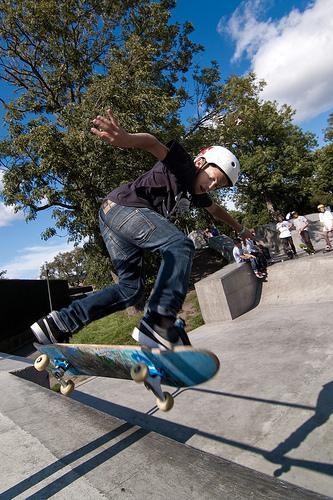Question: what is the person in the foreground doing?
Choices:
A. Roller skating.
B. Surfing.
C. Skateboarding.
D. Riding a bike.
Answer with the letter. Answer: C Question: what is the person in the foreground wearing on their head?
Choices:
A. Knit cap.
B. Helmet.
C. Ball cap.
D. Earphones.
Answer with the letter. Answer: B Question: where is this taking place?
Choices:
A. The game.
B. In a skatepark.
C. The dance.
D. The picnic.
Answer with the letter. Answer: B Question: what is the person in the foreground standing on?
Choices:
A. Sidewalk.
B. Stage.
C. Skateboard.
D. Stairs.
Answer with the letter. Answer: C Question: what kind of pants is the person in the foreground wearing?
Choices:
A. Yoga.
B. Jeans.
C. Shorts.
D. Leggings.
Answer with the letter. Answer: B 